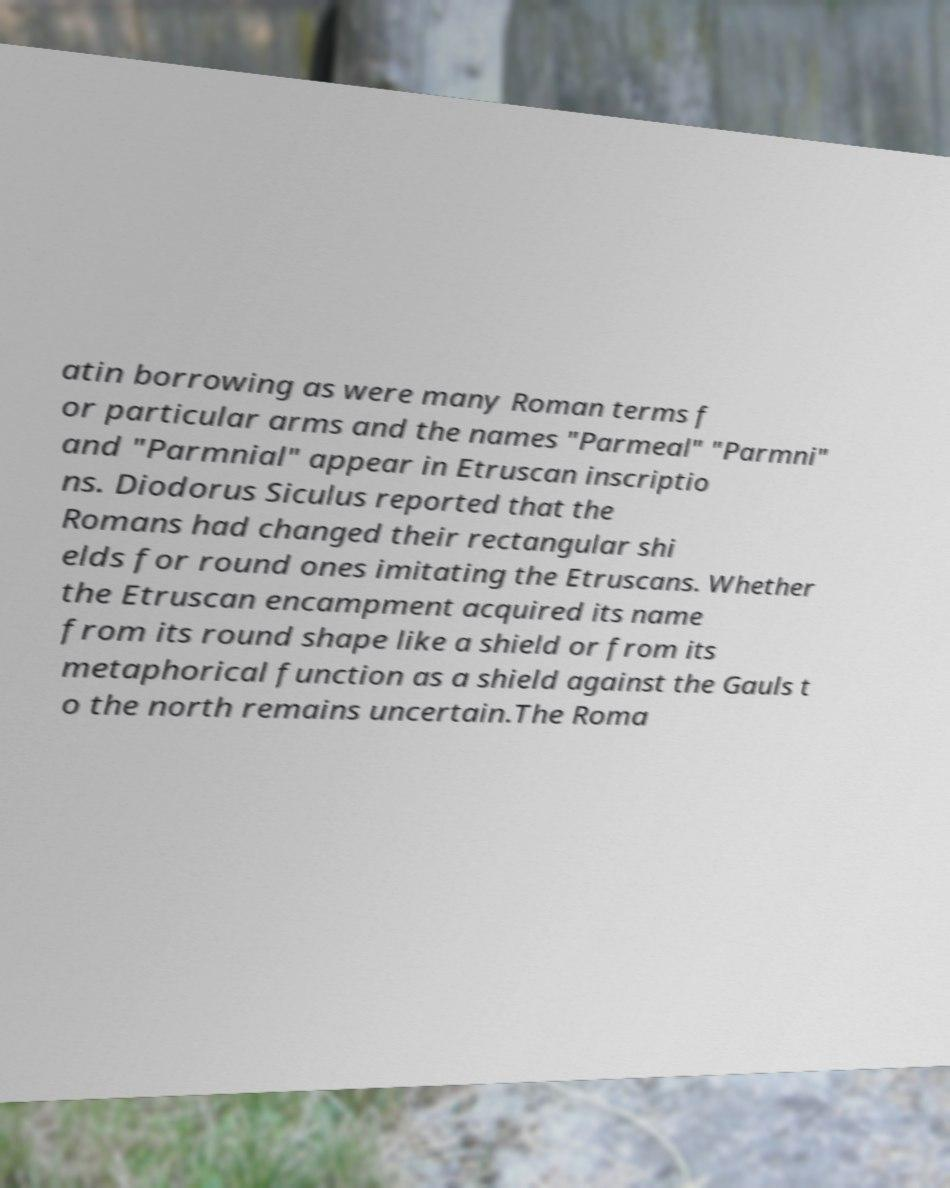What messages or text are displayed in this image? I need them in a readable, typed format. atin borrowing as were many Roman terms f or particular arms and the names "Parmeal" "Parmni" and "Parmnial" appear in Etruscan inscriptio ns. Diodorus Siculus reported that the Romans had changed their rectangular shi elds for round ones imitating the Etruscans. Whether the Etruscan encampment acquired its name from its round shape like a shield or from its metaphorical function as a shield against the Gauls t o the north remains uncertain.The Roma 